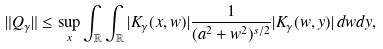Convert formula to latex. <formula><loc_0><loc_0><loc_500><loc_500>\| Q _ { \gamma } \| & \leq \sup _ { x } \int _ { \mathbb { R } } \int _ { \mathbb { R } } | K _ { \gamma } ( x , w ) | \frac { 1 } { ( a ^ { 2 } + w ^ { 2 } ) ^ { s / 2 } } | K _ { \gamma } ( w , y ) | \, d w d y ,</formula> 